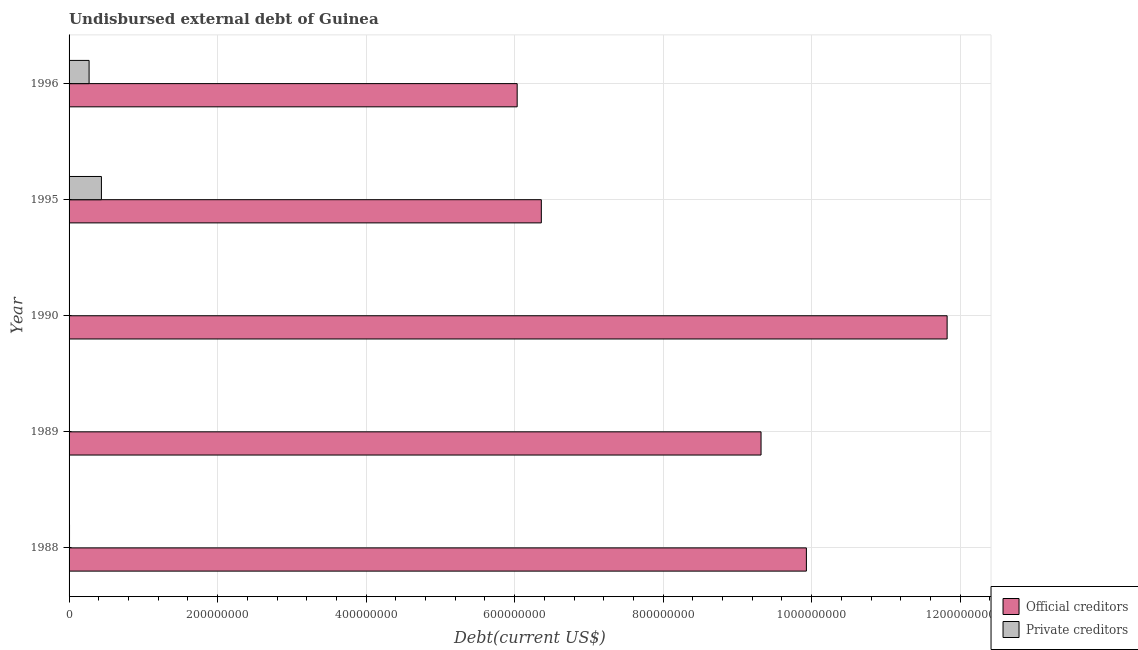How many different coloured bars are there?
Ensure brevity in your answer.  2. Are the number of bars on each tick of the Y-axis equal?
Make the answer very short. Yes. How many bars are there on the 4th tick from the bottom?
Provide a short and direct response. 2. In how many cases, is the number of bars for a given year not equal to the number of legend labels?
Provide a short and direct response. 0. What is the undisbursed external debt of official creditors in 1996?
Your answer should be compact. 6.03e+08. Across all years, what is the maximum undisbursed external debt of official creditors?
Provide a succinct answer. 1.18e+09. Across all years, what is the minimum undisbursed external debt of private creditors?
Provide a short and direct response. 2.89e+05. What is the total undisbursed external debt of private creditors in the graph?
Offer a very short reply. 7.17e+07. What is the difference between the undisbursed external debt of official creditors in 1990 and that in 1996?
Your response must be concise. 5.79e+08. What is the difference between the undisbursed external debt of private creditors in 1990 and the undisbursed external debt of official creditors in 1995?
Offer a terse response. -6.36e+08. What is the average undisbursed external debt of private creditors per year?
Your response must be concise. 1.43e+07. In the year 1990, what is the difference between the undisbursed external debt of private creditors and undisbursed external debt of official creditors?
Provide a succinct answer. -1.18e+09. What is the ratio of the undisbursed external debt of official creditors in 1989 to that in 1995?
Offer a terse response. 1.47. What is the difference between the highest and the second highest undisbursed external debt of private creditors?
Keep it short and to the point. 1.66e+07. What is the difference between the highest and the lowest undisbursed external debt of official creditors?
Your response must be concise. 5.79e+08. What does the 1st bar from the top in 1995 represents?
Give a very brief answer. Private creditors. What does the 1st bar from the bottom in 1989 represents?
Your answer should be very brief. Official creditors. How many bars are there?
Give a very brief answer. 10. Are all the bars in the graph horizontal?
Provide a short and direct response. Yes. How many years are there in the graph?
Make the answer very short. 5. What is the difference between two consecutive major ticks on the X-axis?
Your response must be concise. 2.00e+08. Are the values on the major ticks of X-axis written in scientific E-notation?
Give a very brief answer. No. Does the graph contain any zero values?
Your answer should be compact. No. Does the graph contain grids?
Give a very brief answer. Yes. Where does the legend appear in the graph?
Your answer should be very brief. Bottom right. How are the legend labels stacked?
Your answer should be compact. Vertical. What is the title of the graph?
Provide a succinct answer. Undisbursed external debt of Guinea. Does "Taxes on profits and capital gains" appear as one of the legend labels in the graph?
Your answer should be compact. No. What is the label or title of the X-axis?
Keep it short and to the point. Debt(current US$). What is the Debt(current US$) of Official creditors in 1988?
Keep it short and to the point. 9.93e+08. What is the Debt(current US$) in Private creditors in 1988?
Ensure brevity in your answer.  6.17e+05. What is the Debt(current US$) of Official creditors in 1989?
Ensure brevity in your answer.  9.32e+08. What is the Debt(current US$) in Private creditors in 1989?
Make the answer very short. 2.89e+05. What is the Debt(current US$) in Official creditors in 1990?
Offer a terse response. 1.18e+09. What is the Debt(current US$) of Private creditors in 1990?
Your response must be concise. 2.89e+05. What is the Debt(current US$) of Official creditors in 1995?
Provide a short and direct response. 6.36e+08. What is the Debt(current US$) of Private creditors in 1995?
Provide a succinct answer. 4.36e+07. What is the Debt(current US$) of Official creditors in 1996?
Provide a short and direct response. 6.03e+08. What is the Debt(current US$) of Private creditors in 1996?
Ensure brevity in your answer.  2.70e+07. Across all years, what is the maximum Debt(current US$) in Official creditors?
Your answer should be very brief. 1.18e+09. Across all years, what is the maximum Debt(current US$) of Private creditors?
Your answer should be very brief. 4.36e+07. Across all years, what is the minimum Debt(current US$) in Official creditors?
Provide a succinct answer. 6.03e+08. Across all years, what is the minimum Debt(current US$) in Private creditors?
Provide a succinct answer. 2.89e+05. What is the total Debt(current US$) in Official creditors in the graph?
Provide a short and direct response. 4.35e+09. What is the total Debt(current US$) in Private creditors in the graph?
Your answer should be compact. 7.17e+07. What is the difference between the Debt(current US$) of Official creditors in 1988 and that in 1989?
Offer a very short reply. 6.11e+07. What is the difference between the Debt(current US$) in Private creditors in 1988 and that in 1989?
Provide a short and direct response. 3.28e+05. What is the difference between the Debt(current US$) of Official creditors in 1988 and that in 1990?
Ensure brevity in your answer.  -1.89e+08. What is the difference between the Debt(current US$) in Private creditors in 1988 and that in 1990?
Provide a succinct answer. 3.28e+05. What is the difference between the Debt(current US$) of Official creditors in 1988 and that in 1995?
Ensure brevity in your answer.  3.57e+08. What is the difference between the Debt(current US$) in Private creditors in 1988 and that in 1995?
Provide a short and direct response. -4.30e+07. What is the difference between the Debt(current US$) of Official creditors in 1988 and that in 1996?
Your answer should be compact. 3.89e+08. What is the difference between the Debt(current US$) in Private creditors in 1988 and that in 1996?
Offer a terse response. -2.63e+07. What is the difference between the Debt(current US$) of Official creditors in 1989 and that in 1990?
Offer a very short reply. -2.51e+08. What is the difference between the Debt(current US$) in Private creditors in 1989 and that in 1990?
Keep it short and to the point. 0. What is the difference between the Debt(current US$) in Official creditors in 1989 and that in 1995?
Ensure brevity in your answer.  2.96e+08. What is the difference between the Debt(current US$) in Private creditors in 1989 and that in 1995?
Ensure brevity in your answer.  -4.33e+07. What is the difference between the Debt(current US$) in Official creditors in 1989 and that in 1996?
Keep it short and to the point. 3.28e+08. What is the difference between the Debt(current US$) of Private creditors in 1989 and that in 1996?
Your answer should be very brief. -2.67e+07. What is the difference between the Debt(current US$) in Official creditors in 1990 and that in 1995?
Offer a very short reply. 5.46e+08. What is the difference between the Debt(current US$) in Private creditors in 1990 and that in 1995?
Ensure brevity in your answer.  -4.33e+07. What is the difference between the Debt(current US$) of Official creditors in 1990 and that in 1996?
Provide a short and direct response. 5.79e+08. What is the difference between the Debt(current US$) in Private creditors in 1990 and that in 1996?
Your response must be concise. -2.67e+07. What is the difference between the Debt(current US$) in Official creditors in 1995 and that in 1996?
Make the answer very short. 3.25e+07. What is the difference between the Debt(current US$) in Private creditors in 1995 and that in 1996?
Give a very brief answer. 1.66e+07. What is the difference between the Debt(current US$) of Official creditors in 1988 and the Debt(current US$) of Private creditors in 1989?
Your answer should be compact. 9.93e+08. What is the difference between the Debt(current US$) in Official creditors in 1988 and the Debt(current US$) in Private creditors in 1990?
Provide a short and direct response. 9.93e+08. What is the difference between the Debt(current US$) of Official creditors in 1988 and the Debt(current US$) of Private creditors in 1995?
Give a very brief answer. 9.49e+08. What is the difference between the Debt(current US$) of Official creditors in 1988 and the Debt(current US$) of Private creditors in 1996?
Make the answer very short. 9.66e+08. What is the difference between the Debt(current US$) in Official creditors in 1989 and the Debt(current US$) in Private creditors in 1990?
Your answer should be compact. 9.32e+08. What is the difference between the Debt(current US$) in Official creditors in 1989 and the Debt(current US$) in Private creditors in 1995?
Offer a terse response. 8.88e+08. What is the difference between the Debt(current US$) of Official creditors in 1989 and the Debt(current US$) of Private creditors in 1996?
Keep it short and to the point. 9.05e+08. What is the difference between the Debt(current US$) of Official creditors in 1990 and the Debt(current US$) of Private creditors in 1995?
Offer a very short reply. 1.14e+09. What is the difference between the Debt(current US$) in Official creditors in 1990 and the Debt(current US$) in Private creditors in 1996?
Make the answer very short. 1.16e+09. What is the difference between the Debt(current US$) of Official creditors in 1995 and the Debt(current US$) of Private creditors in 1996?
Your answer should be very brief. 6.09e+08. What is the average Debt(current US$) in Official creditors per year?
Your response must be concise. 8.69e+08. What is the average Debt(current US$) of Private creditors per year?
Provide a short and direct response. 1.43e+07. In the year 1988, what is the difference between the Debt(current US$) of Official creditors and Debt(current US$) of Private creditors?
Your answer should be very brief. 9.92e+08. In the year 1989, what is the difference between the Debt(current US$) of Official creditors and Debt(current US$) of Private creditors?
Offer a terse response. 9.32e+08. In the year 1990, what is the difference between the Debt(current US$) in Official creditors and Debt(current US$) in Private creditors?
Offer a very short reply. 1.18e+09. In the year 1995, what is the difference between the Debt(current US$) of Official creditors and Debt(current US$) of Private creditors?
Give a very brief answer. 5.92e+08. In the year 1996, what is the difference between the Debt(current US$) in Official creditors and Debt(current US$) in Private creditors?
Your answer should be very brief. 5.76e+08. What is the ratio of the Debt(current US$) of Official creditors in 1988 to that in 1989?
Offer a terse response. 1.07. What is the ratio of the Debt(current US$) in Private creditors in 1988 to that in 1989?
Ensure brevity in your answer.  2.13. What is the ratio of the Debt(current US$) in Official creditors in 1988 to that in 1990?
Provide a short and direct response. 0.84. What is the ratio of the Debt(current US$) of Private creditors in 1988 to that in 1990?
Ensure brevity in your answer.  2.13. What is the ratio of the Debt(current US$) of Official creditors in 1988 to that in 1995?
Provide a succinct answer. 1.56. What is the ratio of the Debt(current US$) in Private creditors in 1988 to that in 1995?
Provide a succinct answer. 0.01. What is the ratio of the Debt(current US$) in Official creditors in 1988 to that in 1996?
Your response must be concise. 1.65. What is the ratio of the Debt(current US$) in Private creditors in 1988 to that in 1996?
Offer a very short reply. 0.02. What is the ratio of the Debt(current US$) in Official creditors in 1989 to that in 1990?
Give a very brief answer. 0.79. What is the ratio of the Debt(current US$) of Official creditors in 1989 to that in 1995?
Offer a very short reply. 1.47. What is the ratio of the Debt(current US$) of Private creditors in 1989 to that in 1995?
Ensure brevity in your answer.  0.01. What is the ratio of the Debt(current US$) in Official creditors in 1989 to that in 1996?
Make the answer very short. 1.54. What is the ratio of the Debt(current US$) in Private creditors in 1989 to that in 1996?
Your response must be concise. 0.01. What is the ratio of the Debt(current US$) in Official creditors in 1990 to that in 1995?
Give a very brief answer. 1.86. What is the ratio of the Debt(current US$) of Private creditors in 1990 to that in 1995?
Ensure brevity in your answer.  0.01. What is the ratio of the Debt(current US$) of Official creditors in 1990 to that in 1996?
Provide a succinct answer. 1.96. What is the ratio of the Debt(current US$) in Private creditors in 1990 to that in 1996?
Ensure brevity in your answer.  0.01. What is the ratio of the Debt(current US$) of Official creditors in 1995 to that in 1996?
Provide a succinct answer. 1.05. What is the ratio of the Debt(current US$) in Private creditors in 1995 to that in 1996?
Provide a succinct answer. 1.62. What is the difference between the highest and the second highest Debt(current US$) of Official creditors?
Provide a short and direct response. 1.89e+08. What is the difference between the highest and the second highest Debt(current US$) in Private creditors?
Make the answer very short. 1.66e+07. What is the difference between the highest and the lowest Debt(current US$) of Official creditors?
Give a very brief answer. 5.79e+08. What is the difference between the highest and the lowest Debt(current US$) in Private creditors?
Keep it short and to the point. 4.33e+07. 